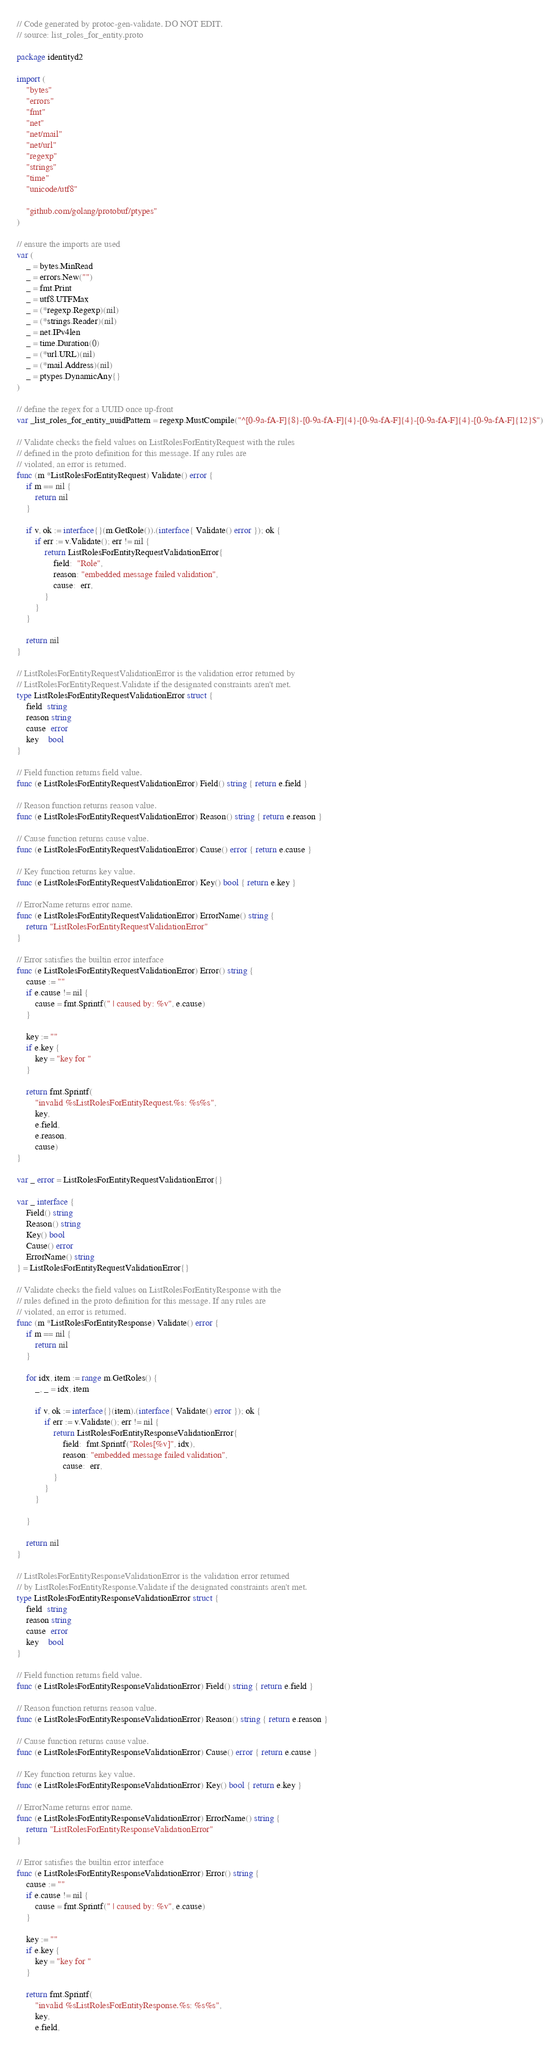Convert code to text. <code><loc_0><loc_0><loc_500><loc_500><_Go_>// Code generated by protoc-gen-validate. DO NOT EDIT.
// source: list_roles_for_entity.proto

package identityd2

import (
	"bytes"
	"errors"
	"fmt"
	"net"
	"net/mail"
	"net/url"
	"regexp"
	"strings"
	"time"
	"unicode/utf8"

	"github.com/golang/protobuf/ptypes"
)

// ensure the imports are used
var (
	_ = bytes.MinRead
	_ = errors.New("")
	_ = fmt.Print
	_ = utf8.UTFMax
	_ = (*regexp.Regexp)(nil)
	_ = (*strings.Reader)(nil)
	_ = net.IPv4len
	_ = time.Duration(0)
	_ = (*url.URL)(nil)
	_ = (*mail.Address)(nil)
	_ = ptypes.DynamicAny{}
)

// define the regex for a UUID once up-front
var _list_roles_for_entity_uuidPattern = regexp.MustCompile("^[0-9a-fA-F]{8}-[0-9a-fA-F]{4}-[0-9a-fA-F]{4}-[0-9a-fA-F]{4}-[0-9a-fA-F]{12}$")

// Validate checks the field values on ListRolesForEntityRequest with the rules
// defined in the proto definition for this message. If any rules are
// violated, an error is returned.
func (m *ListRolesForEntityRequest) Validate() error {
	if m == nil {
		return nil
	}

	if v, ok := interface{}(m.GetRole()).(interface{ Validate() error }); ok {
		if err := v.Validate(); err != nil {
			return ListRolesForEntityRequestValidationError{
				field:  "Role",
				reason: "embedded message failed validation",
				cause:  err,
			}
		}
	}

	return nil
}

// ListRolesForEntityRequestValidationError is the validation error returned by
// ListRolesForEntityRequest.Validate if the designated constraints aren't met.
type ListRolesForEntityRequestValidationError struct {
	field  string
	reason string
	cause  error
	key    bool
}

// Field function returns field value.
func (e ListRolesForEntityRequestValidationError) Field() string { return e.field }

// Reason function returns reason value.
func (e ListRolesForEntityRequestValidationError) Reason() string { return e.reason }

// Cause function returns cause value.
func (e ListRolesForEntityRequestValidationError) Cause() error { return e.cause }

// Key function returns key value.
func (e ListRolesForEntityRequestValidationError) Key() bool { return e.key }

// ErrorName returns error name.
func (e ListRolesForEntityRequestValidationError) ErrorName() string {
	return "ListRolesForEntityRequestValidationError"
}

// Error satisfies the builtin error interface
func (e ListRolesForEntityRequestValidationError) Error() string {
	cause := ""
	if e.cause != nil {
		cause = fmt.Sprintf(" | caused by: %v", e.cause)
	}

	key := ""
	if e.key {
		key = "key for "
	}

	return fmt.Sprintf(
		"invalid %sListRolesForEntityRequest.%s: %s%s",
		key,
		e.field,
		e.reason,
		cause)
}

var _ error = ListRolesForEntityRequestValidationError{}

var _ interface {
	Field() string
	Reason() string
	Key() bool
	Cause() error
	ErrorName() string
} = ListRolesForEntityRequestValidationError{}

// Validate checks the field values on ListRolesForEntityResponse with the
// rules defined in the proto definition for this message. If any rules are
// violated, an error is returned.
func (m *ListRolesForEntityResponse) Validate() error {
	if m == nil {
		return nil
	}

	for idx, item := range m.GetRoles() {
		_, _ = idx, item

		if v, ok := interface{}(item).(interface{ Validate() error }); ok {
			if err := v.Validate(); err != nil {
				return ListRolesForEntityResponseValidationError{
					field:  fmt.Sprintf("Roles[%v]", idx),
					reason: "embedded message failed validation",
					cause:  err,
				}
			}
		}

	}

	return nil
}

// ListRolesForEntityResponseValidationError is the validation error returned
// by ListRolesForEntityResponse.Validate if the designated constraints aren't met.
type ListRolesForEntityResponseValidationError struct {
	field  string
	reason string
	cause  error
	key    bool
}

// Field function returns field value.
func (e ListRolesForEntityResponseValidationError) Field() string { return e.field }

// Reason function returns reason value.
func (e ListRolesForEntityResponseValidationError) Reason() string { return e.reason }

// Cause function returns cause value.
func (e ListRolesForEntityResponseValidationError) Cause() error { return e.cause }

// Key function returns key value.
func (e ListRolesForEntityResponseValidationError) Key() bool { return e.key }

// ErrorName returns error name.
func (e ListRolesForEntityResponseValidationError) ErrorName() string {
	return "ListRolesForEntityResponseValidationError"
}

// Error satisfies the builtin error interface
func (e ListRolesForEntityResponseValidationError) Error() string {
	cause := ""
	if e.cause != nil {
		cause = fmt.Sprintf(" | caused by: %v", e.cause)
	}

	key := ""
	if e.key {
		key = "key for "
	}

	return fmt.Sprintf(
		"invalid %sListRolesForEntityResponse.%s: %s%s",
		key,
		e.field,</code> 